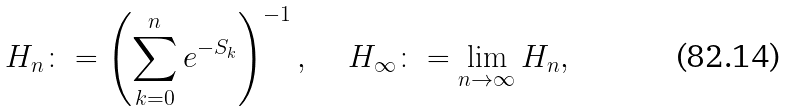<formula> <loc_0><loc_0><loc_500><loc_500>H _ { n } \colon = \left ( \sum _ { k = 0 } ^ { n } e ^ { - S _ { k } } \right ) ^ { - 1 } , \, \quad H _ { \infty } \colon = \lim _ { n \rightarrow \infty } H _ { n } ,</formula> 